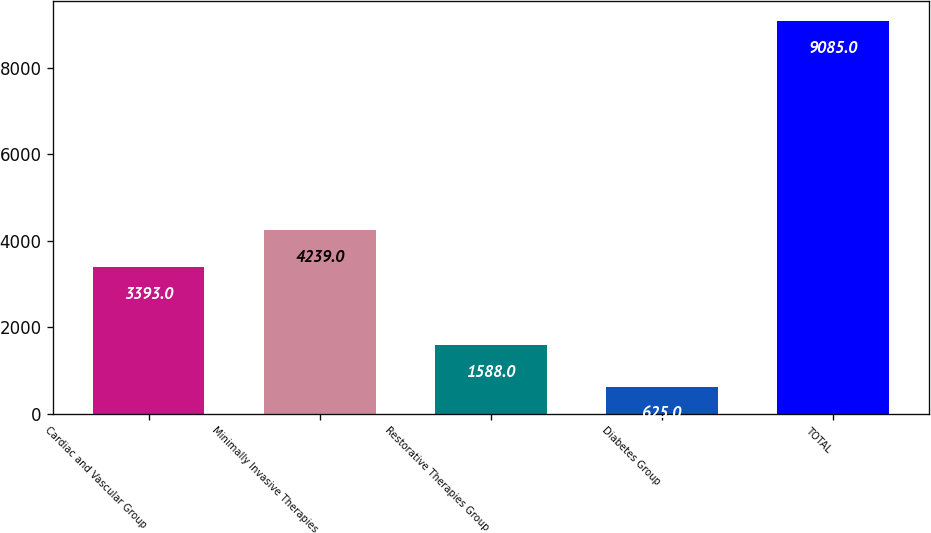Convert chart. <chart><loc_0><loc_0><loc_500><loc_500><bar_chart><fcel>Cardiac and Vascular Group<fcel>Minimally Invasive Therapies<fcel>Restorative Therapies Group<fcel>Diabetes Group<fcel>TOTAL<nl><fcel>3393<fcel>4239<fcel>1588<fcel>625<fcel>9085<nl></chart> 